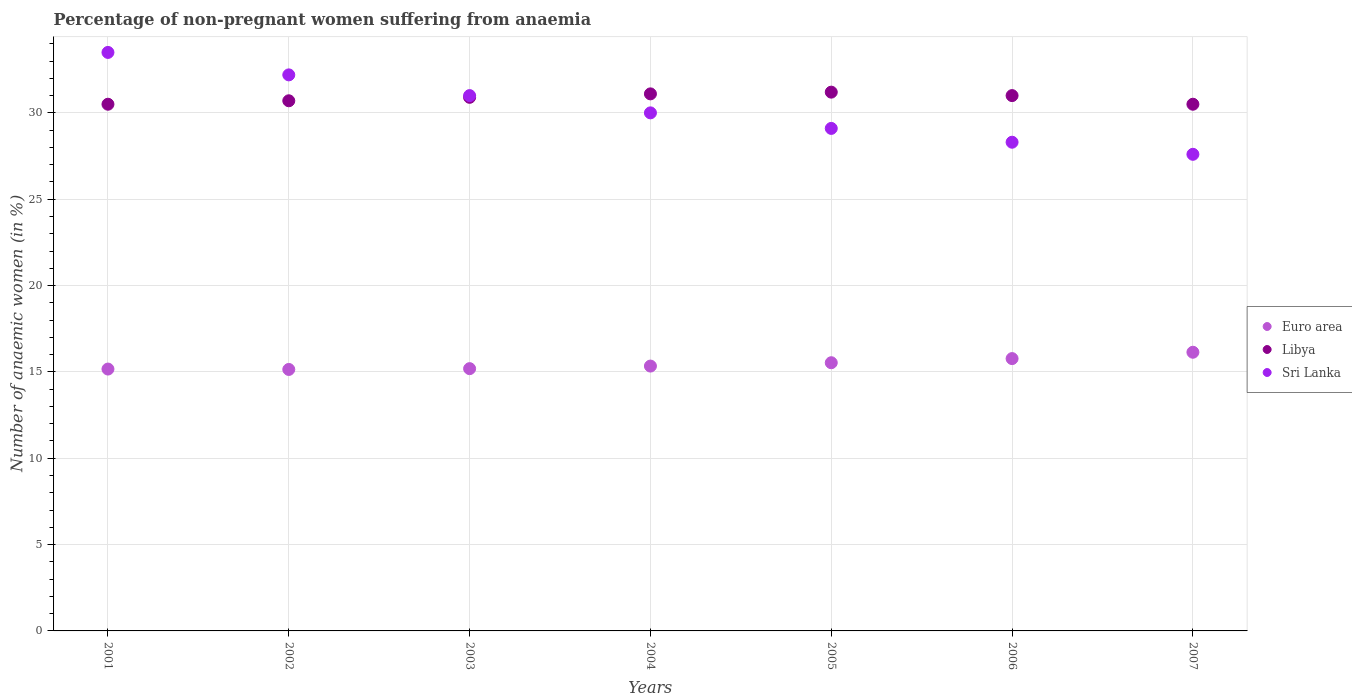How many different coloured dotlines are there?
Keep it short and to the point. 3. What is the percentage of non-pregnant women suffering from anaemia in Libya in 2007?
Provide a short and direct response. 30.5. Across all years, what is the maximum percentage of non-pregnant women suffering from anaemia in Libya?
Make the answer very short. 31.2. Across all years, what is the minimum percentage of non-pregnant women suffering from anaemia in Libya?
Offer a terse response. 30.5. In which year was the percentage of non-pregnant women suffering from anaemia in Sri Lanka minimum?
Offer a very short reply. 2007. What is the total percentage of non-pregnant women suffering from anaemia in Euro area in the graph?
Your answer should be compact. 108.27. What is the difference between the percentage of non-pregnant women suffering from anaemia in Libya in 2004 and that in 2005?
Your response must be concise. -0.1. What is the difference between the percentage of non-pregnant women suffering from anaemia in Euro area in 2004 and the percentage of non-pregnant women suffering from anaemia in Sri Lanka in 2003?
Offer a terse response. -15.66. What is the average percentage of non-pregnant women suffering from anaemia in Sri Lanka per year?
Your response must be concise. 30.24. In the year 2004, what is the difference between the percentage of non-pregnant women suffering from anaemia in Sri Lanka and percentage of non-pregnant women suffering from anaemia in Euro area?
Offer a very short reply. 14.66. What is the ratio of the percentage of non-pregnant women suffering from anaemia in Libya in 2002 to that in 2003?
Your answer should be very brief. 0.99. Is the percentage of non-pregnant women suffering from anaemia in Sri Lanka in 2004 less than that in 2007?
Provide a short and direct response. No. What is the difference between the highest and the second highest percentage of non-pregnant women suffering from anaemia in Libya?
Your response must be concise. 0.1. What is the difference between the highest and the lowest percentage of non-pregnant women suffering from anaemia in Libya?
Your response must be concise. 0.7. Is the sum of the percentage of non-pregnant women suffering from anaemia in Sri Lanka in 2001 and 2006 greater than the maximum percentage of non-pregnant women suffering from anaemia in Libya across all years?
Make the answer very short. Yes. Is the percentage of non-pregnant women suffering from anaemia in Euro area strictly greater than the percentage of non-pregnant women suffering from anaemia in Libya over the years?
Provide a succinct answer. No. Is the percentage of non-pregnant women suffering from anaemia in Sri Lanka strictly less than the percentage of non-pregnant women suffering from anaemia in Euro area over the years?
Your response must be concise. No. How many dotlines are there?
Offer a very short reply. 3. How many years are there in the graph?
Your answer should be very brief. 7. Are the values on the major ticks of Y-axis written in scientific E-notation?
Provide a succinct answer. No. Where does the legend appear in the graph?
Provide a short and direct response. Center right. How many legend labels are there?
Give a very brief answer. 3. How are the legend labels stacked?
Make the answer very short. Vertical. What is the title of the graph?
Offer a very short reply. Percentage of non-pregnant women suffering from anaemia. What is the label or title of the Y-axis?
Provide a succinct answer. Number of anaemic women (in %). What is the Number of anaemic women (in %) in Euro area in 2001?
Ensure brevity in your answer.  15.16. What is the Number of anaemic women (in %) of Libya in 2001?
Keep it short and to the point. 30.5. What is the Number of anaemic women (in %) in Sri Lanka in 2001?
Make the answer very short. 33.5. What is the Number of anaemic women (in %) in Euro area in 2002?
Make the answer very short. 15.14. What is the Number of anaemic women (in %) in Libya in 2002?
Your answer should be compact. 30.7. What is the Number of anaemic women (in %) in Sri Lanka in 2002?
Offer a terse response. 32.2. What is the Number of anaemic women (in %) of Euro area in 2003?
Keep it short and to the point. 15.19. What is the Number of anaemic women (in %) in Libya in 2003?
Offer a very short reply. 30.9. What is the Number of anaemic women (in %) of Euro area in 2004?
Your answer should be compact. 15.34. What is the Number of anaemic women (in %) of Libya in 2004?
Offer a very short reply. 31.1. What is the Number of anaemic women (in %) in Euro area in 2005?
Keep it short and to the point. 15.53. What is the Number of anaemic women (in %) in Libya in 2005?
Provide a short and direct response. 31.2. What is the Number of anaemic women (in %) in Sri Lanka in 2005?
Make the answer very short. 29.1. What is the Number of anaemic women (in %) in Euro area in 2006?
Your response must be concise. 15.77. What is the Number of anaemic women (in %) in Sri Lanka in 2006?
Your answer should be very brief. 28.3. What is the Number of anaemic women (in %) of Euro area in 2007?
Give a very brief answer. 16.14. What is the Number of anaemic women (in %) in Libya in 2007?
Ensure brevity in your answer.  30.5. What is the Number of anaemic women (in %) of Sri Lanka in 2007?
Provide a succinct answer. 27.6. Across all years, what is the maximum Number of anaemic women (in %) of Euro area?
Make the answer very short. 16.14. Across all years, what is the maximum Number of anaemic women (in %) in Libya?
Your answer should be compact. 31.2. Across all years, what is the maximum Number of anaemic women (in %) in Sri Lanka?
Give a very brief answer. 33.5. Across all years, what is the minimum Number of anaemic women (in %) in Euro area?
Your answer should be very brief. 15.14. Across all years, what is the minimum Number of anaemic women (in %) in Libya?
Provide a succinct answer. 30.5. Across all years, what is the minimum Number of anaemic women (in %) of Sri Lanka?
Your response must be concise. 27.6. What is the total Number of anaemic women (in %) of Euro area in the graph?
Give a very brief answer. 108.27. What is the total Number of anaemic women (in %) in Libya in the graph?
Offer a terse response. 215.9. What is the total Number of anaemic women (in %) of Sri Lanka in the graph?
Your answer should be compact. 211.7. What is the difference between the Number of anaemic women (in %) in Euro area in 2001 and that in 2002?
Your response must be concise. 0.02. What is the difference between the Number of anaemic women (in %) in Libya in 2001 and that in 2002?
Make the answer very short. -0.2. What is the difference between the Number of anaemic women (in %) of Euro area in 2001 and that in 2003?
Make the answer very short. -0.02. What is the difference between the Number of anaemic women (in %) of Libya in 2001 and that in 2003?
Provide a succinct answer. -0.4. What is the difference between the Number of anaemic women (in %) in Sri Lanka in 2001 and that in 2003?
Your response must be concise. 2.5. What is the difference between the Number of anaemic women (in %) of Euro area in 2001 and that in 2004?
Your response must be concise. -0.17. What is the difference between the Number of anaemic women (in %) in Euro area in 2001 and that in 2005?
Provide a short and direct response. -0.37. What is the difference between the Number of anaemic women (in %) in Euro area in 2001 and that in 2006?
Provide a succinct answer. -0.61. What is the difference between the Number of anaemic women (in %) of Libya in 2001 and that in 2006?
Your answer should be compact. -0.5. What is the difference between the Number of anaemic women (in %) of Sri Lanka in 2001 and that in 2006?
Your answer should be compact. 5.2. What is the difference between the Number of anaemic women (in %) in Euro area in 2001 and that in 2007?
Your response must be concise. -0.97. What is the difference between the Number of anaemic women (in %) of Sri Lanka in 2001 and that in 2007?
Make the answer very short. 5.9. What is the difference between the Number of anaemic women (in %) in Euro area in 2002 and that in 2003?
Your answer should be very brief. -0.05. What is the difference between the Number of anaemic women (in %) of Euro area in 2002 and that in 2004?
Keep it short and to the point. -0.2. What is the difference between the Number of anaemic women (in %) of Sri Lanka in 2002 and that in 2004?
Your answer should be compact. 2.2. What is the difference between the Number of anaemic women (in %) in Euro area in 2002 and that in 2005?
Ensure brevity in your answer.  -0.39. What is the difference between the Number of anaemic women (in %) of Libya in 2002 and that in 2005?
Make the answer very short. -0.5. What is the difference between the Number of anaemic women (in %) of Euro area in 2002 and that in 2006?
Your answer should be compact. -0.63. What is the difference between the Number of anaemic women (in %) in Libya in 2002 and that in 2006?
Provide a succinct answer. -0.3. What is the difference between the Number of anaemic women (in %) in Euro area in 2002 and that in 2007?
Keep it short and to the point. -1. What is the difference between the Number of anaemic women (in %) of Libya in 2002 and that in 2007?
Your response must be concise. 0.2. What is the difference between the Number of anaemic women (in %) of Sri Lanka in 2002 and that in 2007?
Offer a very short reply. 4.6. What is the difference between the Number of anaemic women (in %) of Euro area in 2003 and that in 2004?
Provide a succinct answer. -0.15. What is the difference between the Number of anaemic women (in %) of Libya in 2003 and that in 2004?
Make the answer very short. -0.2. What is the difference between the Number of anaemic women (in %) in Sri Lanka in 2003 and that in 2004?
Provide a succinct answer. 1. What is the difference between the Number of anaemic women (in %) in Euro area in 2003 and that in 2005?
Keep it short and to the point. -0.34. What is the difference between the Number of anaemic women (in %) in Libya in 2003 and that in 2005?
Provide a succinct answer. -0.3. What is the difference between the Number of anaemic women (in %) of Euro area in 2003 and that in 2006?
Your response must be concise. -0.58. What is the difference between the Number of anaemic women (in %) of Sri Lanka in 2003 and that in 2006?
Ensure brevity in your answer.  2.7. What is the difference between the Number of anaemic women (in %) of Euro area in 2003 and that in 2007?
Offer a very short reply. -0.95. What is the difference between the Number of anaemic women (in %) in Sri Lanka in 2003 and that in 2007?
Offer a terse response. 3.4. What is the difference between the Number of anaemic women (in %) in Euro area in 2004 and that in 2005?
Your response must be concise. -0.19. What is the difference between the Number of anaemic women (in %) in Sri Lanka in 2004 and that in 2005?
Your answer should be compact. 0.9. What is the difference between the Number of anaemic women (in %) in Euro area in 2004 and that in 2006?
Provide a short and direct response. -0.43. What is the difference between the Number of anaemic women (in %) of Libya in 2004 and that in 2006?
Provide a succinct answer. 0.1. What is the difference between the Number of anaemic women (in %) of Euro area in 2004 and that in 2007?
Your answer should be very brief. -0.8. What is the difference between the Number of anaemic women (in %) in Libya in 2004 and that in 2007?
Your response must be concise. 0.6. What is the difference between the Number of anaemic women (in %) of Sri Lanka in 2004 and that in 2007?
Provide a succinct answer. 2.4. What is the difference between the Number of anaemic women (in %) of Euro area in 2005 and that in 2006?
Provide a succinct answer. -0.24. What is the difference between the Number of anaemic women (in %) in Libya in 2005 and that in 2006?
Keep it short and to the point. 0.2. What is the difference between the Number of anaemic women (in %) of Sri Lanka in 2005 and that in 2006?
Keep it short and to the point. 0.8. What is the difference between the Number of anaemic women (in %) of Euro area in 2005 and that in 2007?
Give a very brief answer. -0.61. What is the difference between the Number of anaemic women (in %) of Libya in 2005 and that in 2007?
Offer a very short reply. 0.7. What is the difference between the Number of anaemic women (in %) of Euro area in 2006 and that in 2007?
Keep it short and to the point. -0.37. What is the difference between the Number of anaemic women (in %) in Libya in 2006 and that in 2007?
Make the answer very short. 0.5. What is the difference between the Number of anaemic women (in %) of Sri Lanka in 2006 and that in 2007?
Your answer should be very brief. 0.7. What is the difference between the Number of anaemic women (in %) in Euro area in 2001 and the Number of anaemic women (in %) in Libya in 2002?
Your answer should be compact. -15.54. What is the difference between the Number of anaemic women (in %) of Euro area in 2001 and the Number of anaemic women (in %) of Sri Lanka in 2002?
Make the answer very short. -17.04. What is the difference between the Number of anaemic women (in %) of Euro area in 2001 and the Number of anaemic women (in %) of Libya in 2003?
Your response must be concise. -15.74. What is the difference between the Number of anaemic women (in %) in Euro area in 2001 and the Number of anaemic women (in %) in Sri Lanka in 2003?
Your answer should be compact. -15.84. What is the difference between the Number of anaemic women (in %) of Euro area in 2001 and the Number of anaemic women (in %) of Libya in 2004?
Your answer should be compact. -15.94. What is the difference between the Number of anaemic women (in %) of Euro area in 2001 and the Number of anaemic women (in %) of Sri Lanka in 2004?
Your response must be concise. -14.84. What is the difference between the Number of anaemic women (in %) of Libya in 2001 and the Number of anaemic women (in %) of Sri Lanka in 2004?
Keep it short and to the point. 0.5. What is the difference between the Number of anaemic women (in %) of Euro area in 2001 and the Number of anaemic women (in %) of Libya in 2005?
Your answer should be compact. -16.04. What is the difference between the Number of anaemic women (in %) in Euro area in 2001 and the Number of anaemic women (in %) in Sri Lanka in 2005?
Provide a short and direct response. -13.94. What is the difference between the Number of anaemic women (in %) of Libya in 2001 and the Number of anaemic women (in %) of Sri Lanka in 2005?
Keep it short and to the point. 1.4. What is the difference between the Number of anaemic women (in %) in Euro area in 2001 and the Number of anaemic women (in %) in Libya in 2006?
Make the answer very short. -15.84. What is the difference between the Number of anaemic women (in %) of Euro area in 2001 and the Number of anaemic women (in %) of Sri Lanka in 2006?
Provide a short and direct response. -13.14. What is the difference between the Number of anaemic women (in %) of Euro area in 2001 and the Number of anaemic women (in %) of Libya in 2007?
Provide a short and direct response. -15.34. What is the difference between the Number of anaemic women (in %) in Euro area in 2001 and the Number of anaemic women (in %) in Sri Lanka in 2007?
Your response must be concise. -12.44. What is the difference between the Number of anaemic women (in %) in Euro area in 2002 and the Number of anaemic women (in %) in Libya in 2003?
Your answer should be compact. -15.76. What is the difference between the Number of anaemic women (in %) in Euro area in 2002 and the Number of anaemic women (in %) in Sri Lanka in 2003?
Offer a very short reply. -15.86. What is the difference between the Number of anaemic women (in %) in Libya in 2002 and the Number of anaemic women (in %) in Sri Lanka in 2003?
Your answer should be very brief. -0.3. What is the difference between the Number of anaemic women (in %) in Euro area in 2002 and the Number of anaemic women (in %) in Libya in 2004?
Provide a succinct answer. -15.96. What is the difference between the Number of anaemic women (in %) of Euro area in 2002 and the Number of anaemic women (in %) of Sri Lanka in 2004?
Your response must be concise. -14.86. What is the difference between the Number of anaemic women (in %) of Libya in 2002 and the Number of anaemic women (in %) of Sri Lanka in 2004?
Ensure brevity in your answer.  0.7. What is the difference between the Number of anaemic women (in %) in Euro area in 2002 and the Number of anaemic women (in %) in Libya in 2005?
Your answer should be very brief. -16.06. What is the difference between the Number of anaemic women (in %) in Euro area in 2002 and the Number of anaemic women (in %) in Sri Lanka in 2005?
Offer a very short reply. -13.96. What is the difference between the Number of anaemic women (in %) in Libya in 2002 and the Number of anaemic women (in %) in Sri Lanka in 2005?
Keep it short and to the point. 1.6. What is the difference between the Number of anaemic women (in %) in Euro area in 2002 and the Number of anaemic women (in %) in Libya in 2006?
Offer a terse response. -15.86. What is the difference between the Number of anaemic women (in %) of Euro area in 2002 and the Number of anaemic women (in %) of Sri Lanka in 2006?
Your answer should be compact. -13.16. What is the difference between the Number of anaemic women (in %) of Libya in 2002 and the Number of anaemic women (in %) of Sri Lanka in 2006?
Ensure brevity in your answer.  2.4. What is the difference between the Number of anaemic women (in %) in Euro area in 2002 and the Number of anaemic women (in %) in Libya in 2007?
Make the answer very short. -15.36. What is the difference between the Number of anaemic women (in %) in Euro area in 2002 and the Number of anaemic women (in %) in Sri Lanka in 2007?
Make the answer very short. -12.46. What is the difference between the Number of anaemic women (in %) of Libya in 2002 and the Number of anaemic women (in %) of Sri Lanka in 2007?
Ensure brevity in your answer.  3.1. What is the difference between the Number of anaemic women (in %) of Euro area in 2003 and the Number of anaemic women (in %) of Libya in 2004?
Your response must be concise. -15.91. What is the difference between the Number of anaemic women (in %) of Euro area in 2003 and the Number of anaemic women (in %) of Sri Lanka in 2004?
Your response must be concise. -14.81. What is the difference between the Number of anaemic women (in %) of Libya in 2003 and the Number of anaemic women (in %) of Sri Lanka in 2004?
Ensure brevity in your answer.  0.9. What is the difference between the Number of anaemic women (in %) of Euro area in 2003 and the Number of anaemic women (in %) of Libya in 2005?
Your response must be concise. -16.01. What is the difference between the Number of anaemic women (in %) in Euro area in 2003 and the Number of anaemic women (in %) in Sri Lanka in 2005?
Give a very brief answer. -13.91. What is the difference between the Number of anaemic women (in %) in Euro area in 2003 and the Number of anaemic women (in %) in Libya in 2006?
Make the answer very short. -15.81. What is the difference between the Number of anaemic women (in %) of Euro area in 2003 and the Number of anaemic women (in %) of Sri Lanka in 2006?
Keep it short and to the point. -13.11. What is the difference between the Number of anaemic women (in %) in Libya in 2003 and the Number of anaemic women (in %) in Sri Lanka in 2006?
Your response must be concise. 2.6. What is the difference between the Number of anaemic women (in %) of Euro area in 2003 and the Number of anaemic women (in %) of Libya in 2007?
Keep it short and to the point. -15.31. What is the difference between the Number of anaemic women (in %) in Euro area in 2003 and the Number of anaemic women (in %) in Sri Lanka in 2007?
Provide a succinct answer. -12.41. What is the difference between the Number of anaemic women (in %) of Libya in 2003 and the Number of anaemic women (in %) of Sri Lanka in 2007?
Offer a very short reply. 3.3. What is the difference between the Number of anaemic women (in %) of Euro area in 2004 and the Number of anaemic women (in %) of Libya in 2005?
Your answer should be very brief. -15.86. What is the difference between the Number of anaemic women (in %) of Euro area in 2004 and the Number of anaemic women (in %) of Sri Lanka in 2005?
Offer a very short reply. -13.76. What is the difference between the Number of anaemic women (in %) in Libya in 2004 and the Number of anaemic women (in %) in Sri Lanka in 2005?
Your answer should be compact. 2. What is the difference between the Number of anaemic women (in %) of Euro area in 2004 and the Number of anaemic women (in %) of Libya in 2006?
Your response must be concise. -15.66. What is the difference between the Number of anaemic women (in %) in Euro area in 2004 and the Number of anaemic women (in %) in Sri Lanka in 2006?
Make the answer very short. -12.96. What is the difference between the Number of anaemic women (in %) in Euro area in 2004 and the Number of anaemic women (in %) in Libya in 2007?
Your answer should be very brief. -15.16. What is the difference between the Number of anaemic women (in %) in Euro area in 2004 and the Number of anaemic women (in %) in Sri Lanka in 2007?
Provide a succinct answer. -12.26. What is the difference between the Number of anaemic women (in %) in Libya in 2004 and the Number of anaemic women (in %) in Sri Lanka in 2007?
Offer a terse response. 3.5. What is the difference between the Number of anaemic women (in %) in Euro area in 2005 and the Number of anaemic women (in %) in Libya in 2006?
Your answer should be compact. -15.47. What is the difference between the Number of anaemic women (in %) in Euro area in 2005 and the Number of anaemic women (in %) in Sri Lanka in 2006?
Offer a terse response. -12.77. What is the difference between the Number of anaemic women (in %) of Euro area in 2005 and the Number of anaemic women (in %) of Libya in 2007?
Your response must be concise. -14.97. What is the difference between the Number of anaemic women (in %) in Euro area in 2005 and the Number of anaemic women (in %) in Sri Lanka in 2007?
Provide a succinct answer. -12.07. What is the difference between the Number of anaemic women (in %) of Euro area in 2006 and the Number of anaemic women (in %) of Libya in 2007?
Offer a very short reply. -14.73. What is the difference between the Number of anaemic women (in %) of Euro area in 2006 and the Number of anaemic women (in %) of Sri Lanka in 2007?
Make the answer very short. -11.83. What is the average Number of anaemic women (in %) of Euro area per year?
Keep it short and to the point. 15.47. What is the average Number of anaemic women (in %) in Libya per year?
Your answer should be very brief. 30.84. What is the average Number of anaemic women (in %) in Sri Lanka per year?
Provide a short and direct response. 30.24. In the year 2001, what is the difference between the Number of anaemic women (in %) in Euro area and Number of anaemic women (in %) in Libya?
Offer a terse response. -15.34. In the year 2001, what is the difference between the Number of anaemic women (in %) of Euro area and Number of anaemic women (in %) of Sri Lanka?
Ensure brevity in your answer.  -18.34. In the year 2001, what is the difference between the Number of anaemic women (in %) of Libya and Number of anaemic women (in %) of Sri Lanka?
Your answer should be very brief. -3. In the year 2002, what is the difference between the Number of anaemic women (in %) in Euro area and Number of anaemic women (in %) in Libya?
Your answer should be compact. -15.56. In the year 2002, what is the difference between the Number of anaemic women (in %) in Euro area and Number of anaemic women (in %) in Sri Lanka?
Offer a terse response. -17.06. In the year 2002, what is the difference between the Number of anaemic women (in %) in Libya and Number of anaemic women (in %) in Sri Lanka?
Make the answer very short. -1.5. In the year 2003, what is the difference between the Number of anaemic women (in %) of Euro area and Number of anaemic women (in %) of Libya?
Provide a succinct answer. -15.71. In the year 2003, what is the difference between the Number of anaemic women (in %) of Euro area and Number of anaemic women (in %) of Sri Lanka?
Provide a succinct answer. -15.81. In the year 2004, what is the difference between the Number of anaemic women (in %) of Euro area and Number of anaemic women (in %) of Libya?
Offer a terse response. -15.76. In the year 2004, what is the difference between the Number of anaemic women (in %) in Euro area and Number of anaemic women (in %) in Sri Lanka?
Provide a short and direct response. -14.66. In the year 2005, what is the difference between the Number of anaemic women (in %) in Euro area and Number of anaemic women (in %) in Libya?
Make the answer very short. -15.67. In the year 2005, what is the difference between the Number of anaemic women (in %) in Euro area and Number of anaemic women (in %) in Sri Lanka?
Offer a very short reply. -13.57. In the year 2005, what is the difference between the Number of anaemic women (in %) of Libya and Number of anaemic women (in %) of Sri Lanka?
Ensure brevity in your answer.  2.1. In the year 2006, what is the difference between the Number of anaemic women (in %) in Euro area and Number of anaemic women (in %) in Libya?
Your answer should be very brief. -15.23. In the year 2006, what is the difference between the Number of anaemic women (in %) in Euro area and Number of anaemic women (in %) in Sri Lanka?
Offer a very short reply. -12.53. In the year 2006, what is the difference between the Number of anaemic women (in %) of Libya and Number of anaemic women (in %) of Sri Lanka?
Your response must be concise. 2.7. In the year 2007, what is the difference between the Number of anaemic women (in %) in Euro area and Number of anaemic women (in %) in Libya?
Ensure brevity in your answer.  -14.36. In the year 2007, what is the difference between the Number of anaemic women (in %) in Euro area and Number of anaemic women (in %) in Sri Lanka?
Your answer should be compact. -11.46. In the year 2007, what is the difference between the Number of anaemic women (in %) of Libya and Number of anaemic women (in %) of Sri Lanka?
Provide a short and direct response. 2.9. What is the ratio of the Number of anaemic women (in %) of Libya in 2001 to that in 2002?
Your answer should be compact. 0.99. What is the ratio of the Number of anaemic women (in %) in Sri Lanka in 2001 to that in 2002?
Offer a very short reply. 1.04. What is the ratio of the Number of anaemic women (in %) in Libya in 2001 to that in 2003?
Provide a succinct answer. 0.99. What is the ratio of the Number of anaemic women (in %) of Sri Lanka in 2001 to that in 2003?
Your response must be concise. 1.08. What is the ratio of the Number of anaemic women (in %) of Euro area in 2001 to that in 2004?
Your answer should be compact. 0.99. What is the ratio of the Number of anaemic women (in %) of Libya in 2001 to that in 2004?
Provide a short and direct response. 0.98. What is the ratio of the Number of anaemic women (in %) of Sri Lanka in 2001 to that in 2004?
Provide a short and direct response. 1.12. What is the ratio of the Number of anaemic women (in %) in Euro area in 2001 to that in 2005?
Provide a succinct answer. 0.98. What is the ratio of the Number of anaemic women (in %) of Libya in 2001 to that in 2005?
Make the answer very short. 0.98. What is the ratio of the Number of anaemic women (in %) in Sri Lanka in 2001 to that in 2005?
Keep it short and to the point. 1.15. What is the ratio of the Number of anaemic women (in %) in Euro area in 2001 to that in 2006?
Give a very brief answer. 0.96. What is the ratio of the Number of anaemic women (in %) in Libya in 2001 to that in 2006?
Ensure brevity in your answer.  0.98. What is the ratio of the Number of anaemic women (in %) in Sri Lanka in 2001 to that in 2006?
Your response must be concise. 1.18. What is the ratio of the Number of anaemic women (in %) in Euro area in 2001 to that in 2007?
Provide a succinct answer. 0.94. What is the ratio of the Number of anaemic women (in %) in Libya in 2001 to that in 2007?
Your response must be concise. 1. What is the ratio of the Number of anaemic women (in %) of Sri Lanka in 2001 to that in 2007?
Provide a succinct answer. 1.21. What is the ratio of the Number of anaemic women (in %) in Euro area in 2002 to that in 2003?
Give a very brief answer. 1. What is the ratio of the Number of anaemic women (in %) of Sri Lanka in 2002 to that in 2003?
Keep it short and to the point. 1.04. What is the ratio of the Number of anaemic women (in %) of Euro area in 2002 to that in 2004?
Offer a very short reply. 0.99. What is the ratio of the Number of anaemic women (in %) of Libya in 2002 to that in 2004?
Your answer should be very brief. 0.99. What is the ratio of the Number of anaemic women (in %) in Sri Lanka in 2002 to that in 2004?
Provide a succinct answer. 1.07. What is the ratio of the Number of anaemic women (in %) of Euro area in 2002 to that in 2005?
Provide a succinct answer. 0.97. What is the ratio of the Number of anaemic women (in %) of Libya in 2002 to that in 2005?
Give a very brief answer. 0.98. What is the ratio of the Number of anaemic women (in %) in Sri Lanka in 2002 to that in 2005?
Ensure brevity in your answer.  1.11. What is the ratio of the Number of anaemic women (in %) in Euro area in 2002 to that in 2006?
Provide a succinct answer. 0.96. What is the ratio of the Number of anaemic women (in %) in Libya in 2002 to that in 2006?
Your answer should be compact. 0.99. What is the ratio of the Number of anaemic women (in %) of Sri Lanka in 2002 to that in 2006?
Offer a very short reply. 1.14. What is the ratio of the Number of anaemic women (in %) in Euro area in 2002 to that in 2007?
Provide a succinct answer. 0.94. What is the ratio of the Number of anaemic women (in %) in Libya in 2002 to that in 2007?
Provide a short and direct response. 1.01. What is the ratio of the Number of anaemic women (in %) of Sri Lanka in 2002 to that in 2007?
Provide a short and direct response. 1.17. What is the ratio of the Number of anaemic women (in %) in Euro area in 2003 to that in 2004?
Offer a very short reply. 0.99. What is the ratio of the Number of anaemic women (in %) in Libya in 2003 to that in 2004?
Your answer should be very brief. 0.99. What is the ratio of the Number of anaemic women (in %) in Euro area in 2003 to that in 2005?
Provide a succinct answer. 0.98. What is the ratio of the Number of anaemic women (in %) of Libya in 2003 to that in 2005?
Your answer should be very brief. 0.99. What is the ratio of the Number of anaemic women (in %) of Sri Lanka in 2003 to that in 2005?
Make the answer very short. 1.07. What is the ratio of the Number of anaemic women (in %) of Euro area in 2003 to that in 2006?
Your answer should be very brief. 0.96. What is the ratio of the Number of anaemic women (in %) in Libya in 2003 to that in 2006?
Your answer should be very brief. 1. What is the ratio of the Number of anaemic women (in %) in Sri Lanka in 2003 to that in 2006?
Ensure brevity in your answer.  1.1. What is the ratio of the Number of anaemic women (in %) of Euro area in 2003 to that in 2007?
Make the answer very short. 0.94. What is the ratio of the Number of anaemic women (in %) in Libya in 2003 to that in 2007?
Your answer should be compact. 1.01. What is the ratio of the Number of anaemic women (in %) of Sri Lanka in 2003 to that in 2007?
Offer a terse response. 1.12. What is the ratio of the Number of anaemic women (in %) of Euro area in 2004 to that in 2005?
Your answer should be compact. 0.99. What is the ratio of the Number of anaemic women (in %) of Sri Lanka in 2004 to that in 2005?
Your response must be concise. 1.03. What is the ratio of the Number of anaemic women (in %) of Euro area in 2004 to that in 2006?
Offer a terse response. 0.97. What is the ratio of the Number of anaemic women (in %) of Sri Lanka in 2004 to that in 2006?
Make the answer very short. 1.06. What is the ratio of the Number of anaemic women (in %) of Euro area in 2004 to that in 2007?
Keep it short and to the point. 0.95. What is the ratio of the Number of anaemic women (in %) of Libya in 2004 to that in 2007?
Offer a very short reply. 1.02. What is the ratio of the Number of anaemic women (in %) in Sri Lanka in 2004 to that in 2007?
Your answer should be very brief. 1.09. What is the ratio of the Number of anaemic women (in %) of Euro area in 2005 to that in 2006?
Your answer should be very brief. 0.98. What is the ratio of the Number of anaemic women (in %) of Libya in 2005 to that in 2006?
Ensure brevity in your answer.  1.01. What is the ratio of the Number of anaemic women (in %) in Sri Lanka in 2005 to that in 2006?
Your answer should be very brief. 1.03. What is the ratio of the Number of anaemic women (in %) of Euro area in 2005 to that in 2007?
Ensure brevity in your answer.  0.96. What is the ratio of the Number of anaemic women (in %) of Libya in 2005 to that in 2007?
Provide a short and direct response. 1.02. What is the ratio of the Number of anaemic women (in %) in Sri Lanka in 2005 to that in 2007?
Make the answer very short. 1.05. What is the ratio of the Number of anaemic women (in %) in Euro area in 2006 to that in 2007?
Provide a succinct answer. 0.98. What is the ratio of the Number of anaemic women (in %) in Libya in 2006 to that in 2007?
Offer a terse response. 1.02. What is the ratio of the Number of anaemic women (in %) in Sri Lanka in 2006 to that in 2007?
Your answer should be very brief. 1.03. What is the difference between the highest and the second highest Number of anaemic women (in %) in Euro area?
Your answer should be very brief. 0.37. What is the difference between the highest and the second highest Number of anaemic women (in %) in Libya?
Give a very brief answer. 0.1. What is the difference between the highest and the lowest Number of anaemic women (in %) of Euro area?
Provide a short and direct response. 1. 